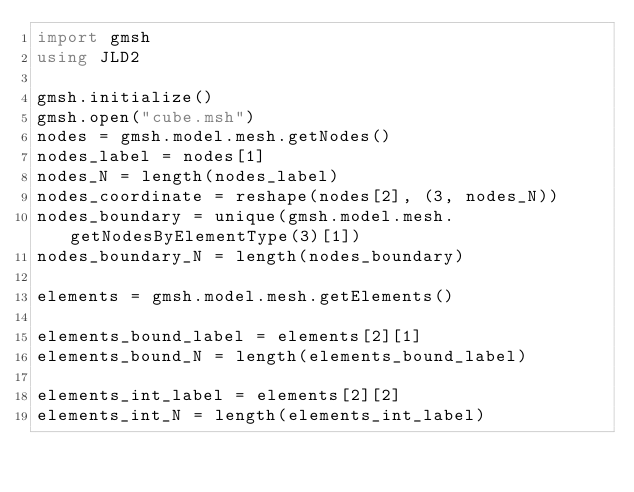Convert code to text. <code><loc_0><loc_0><loc_500><loc_500><_Julia_>import gmsh
using JLD2

gmsh.initialize()
gmsh.open("cube.msh")
nodes = gmsh.model.mesh.getNodes()
nodes_label = nodes[1]
nodes_N = length(nodes_label)
nodes_coordinate = reshape(nodes[2], (3, nodes_N))
nodes_boundary = unique(gmsh.model.mesh.getNodesByElementType(3)[1])
nodes_boundary_N = length(nodes_boundary)

elements = gmsh.model.mesh.getElements()

elements_bound_label = elements[2][1]
elements_bound_N = length(elements_bound_label)

elements_int_label = elements[2][2]
elements_int_N = length(elements_int_label)
</code> 